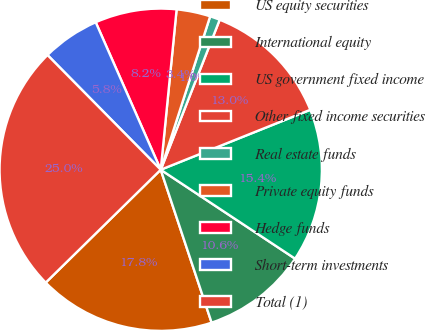Convert chart to OTSL. <chart><loc_0><loc_0><loc_500><loc_500><pie_chart><fcel>US equity securities<fcel>International equity<fcel>US government fixed income<fcel>Other fixed income securities<fcel>Real estate funds<fcel>Private equity funds<fcel>Hedge funds<fcel>Short-term investments<fcel>Total (1)<nl><fcel>17.76%<fcel>10.58%<fcel>15.37%<fcel>12.97%<fcel>1.0%<fcel>3.39%<fcel>8.18%<fcel>5.79%<fcel>24.95%<nl></chart> 